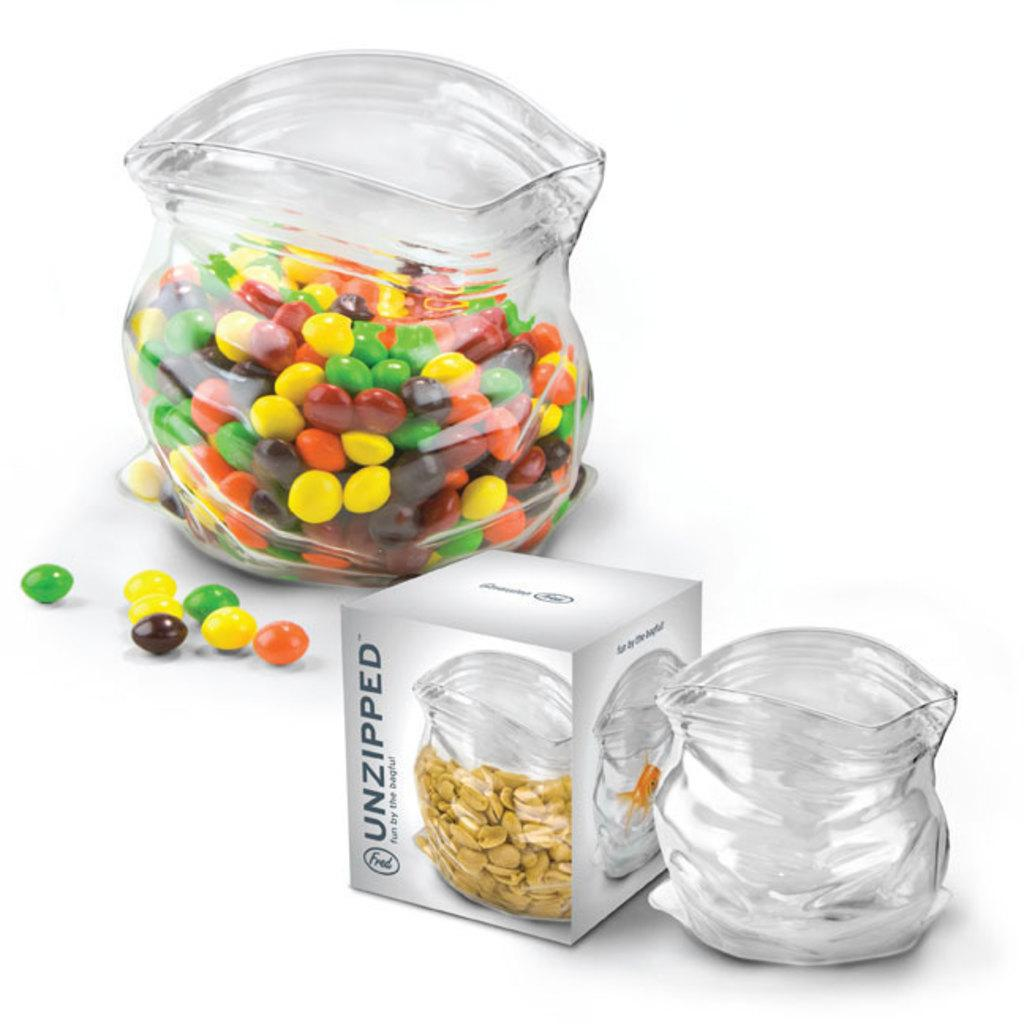What is inside the glass jar in the image? There is a glass jar filled with gems in the image. Can you describe any other jars in the image? Yes, there is another jar in the image. What else can be seen in the image besides the jars? There is a box in the image. Are there any gems outside of the jar in the image? Yes, there are leftover gems on the surface in the image. What type of body language can be seen on the gems in the image? Gems do not exhibit body language, as they are inanimate objects. 